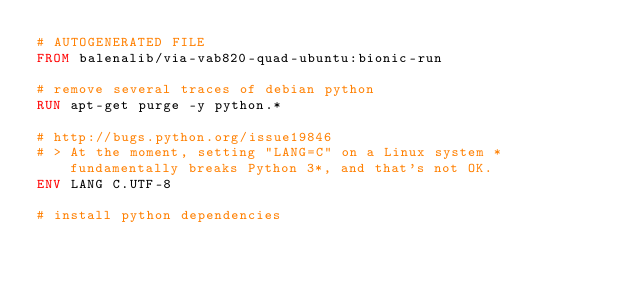<code> <loc_0><loc_0><loc_500><loc_500><_Dockerfile_># AUTOGENERATED FILE
FROM balenalib/via-vab820-quad-ubuntu:bionic-run

# remove several traces of debian python
RUN apt-get purge -y python.*

# http://bugs.python.org/issue19846
# > At the moment, setting "LANG=C" on a Linux system *fundamentally breaks Python 3*, and that's not OK.
ENV LANG C.UTF-8

# install python dependencies</code> 